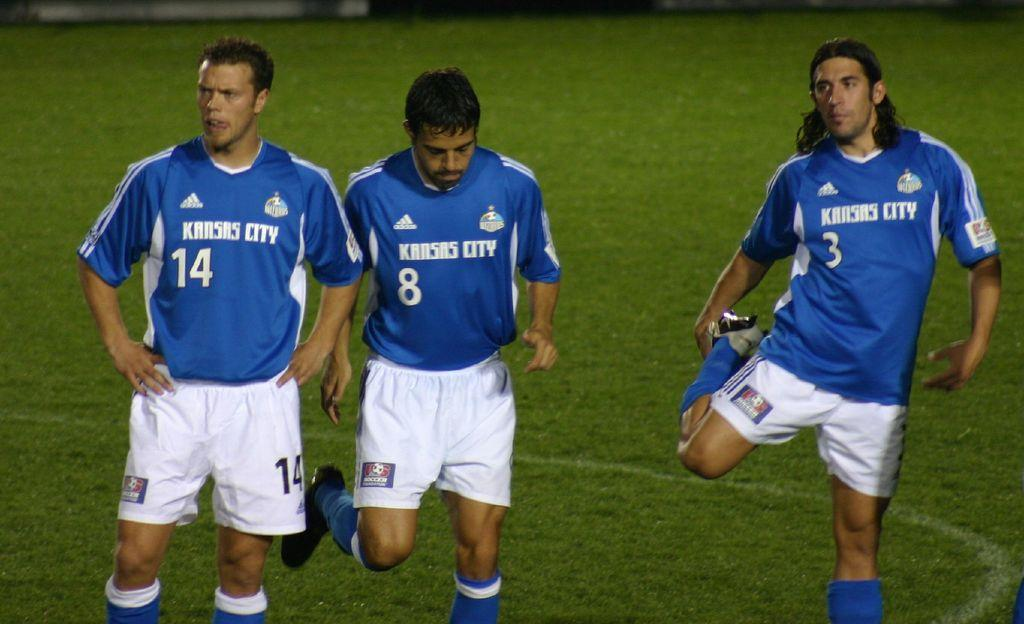What is happening in the center of the image? There are persons standing in the center of the image. What type of terrain is visible in the background of the image? There is grass on the ground in the background of the image. What type of guide is present in the image? There is no guide present in the image; it only shows persons standing in the center and grass in the background. 